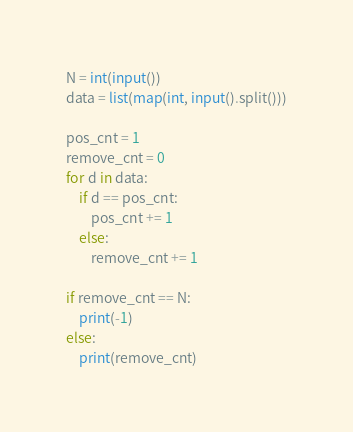<code> <loc_0><loc_0><loc_500><loc_500><_Python_>N = int(input())
data = list(map(int, input().split()))

pos_cnt = 1
remove_cnt = 0
for d in data:
    if d == pos_cnt:
        pos_cnt += 1
    else:
        remove_cnt += 1

if remove_cnt == N:
    print(-1)
else:
    print(remove_cnt)
</code> 